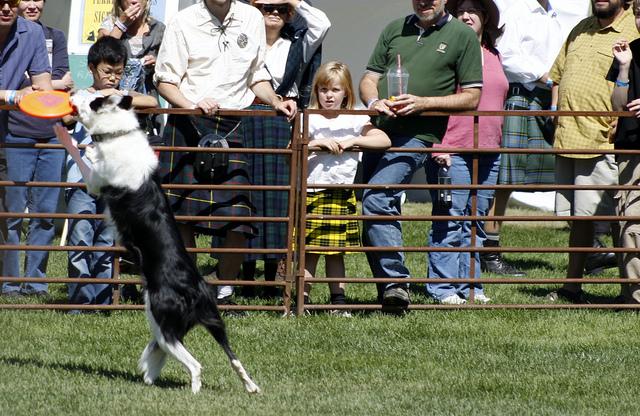What is the dog playing with?
Short answer required. Frisbee. The green-shirted man has something on which wrist?
Be succinct. Right. What kind of animal is this?
Quick response, please. Dog. 